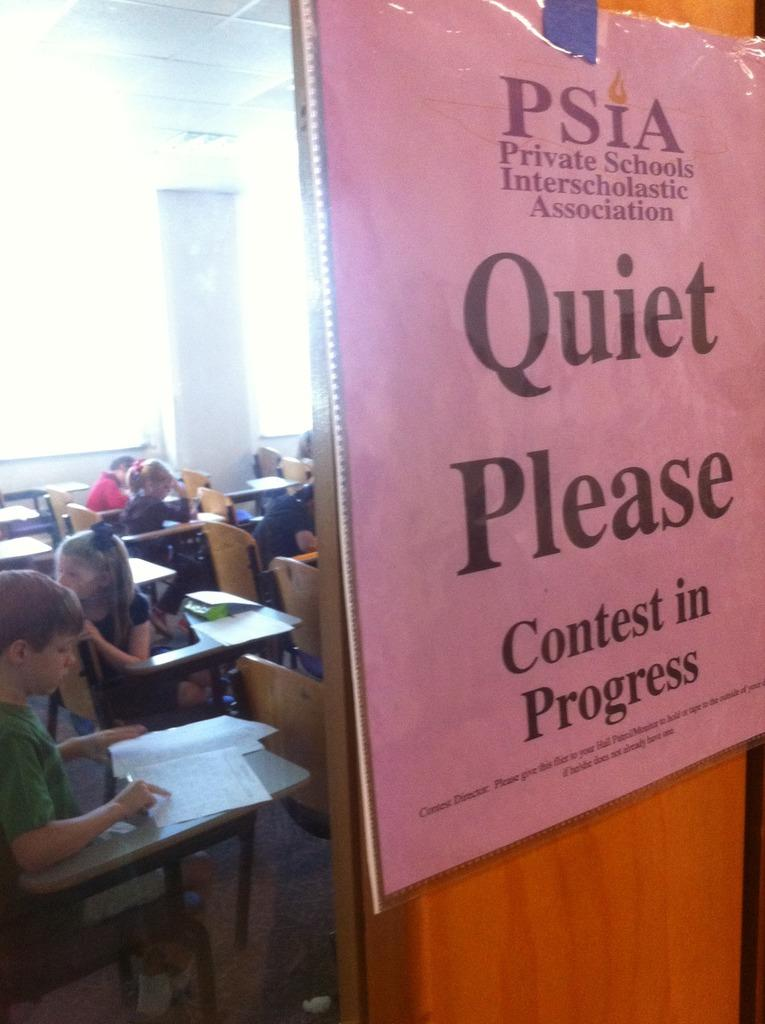<image>
Present a compact description of the photo's key features. The pink sign on the door says quiet please on behalf of the Private Schools Interscholastic Association. 